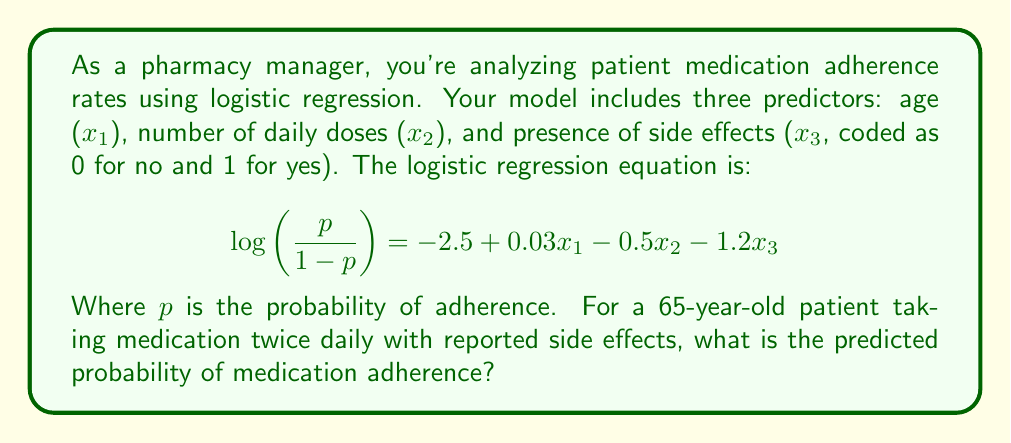Can you solve this math problem? To solve this problem, we'll follow these steps:

1. Identify the values for each predictor:
   $x_1$ (age) = 65
   $x_2$ (number of daily doses) = 2
   $x_3$ (presence of side effects) = 1

2. Substitute these values into the logistic regression equation:

   $$\log\left(\frac{p}{1-p}\right) = -2.5 + 0.03(65) - 0.5(2) - 1.2(1)$$

3. Calculate the right-hand side:

   $$\log\left(\frac{p}{1-p}\right) = -2.5 + 1.95 - 1 - 1.2 = -2.75$$

4. This gives us the log-odds. To find p, we need to apply the inverse logit function:

   $$p = \frac{e^{-2.75}}{1 + e^{-2.75}}$$

5. Calculate this value:

   $$p = \frac{0.0639}{1 + 0.0639} = 0.0601$$

6. Convert to a percentage:

   0.0601 * 100 = 6.01%

Therefore, the predicted probability of medication adherence for this patient is approximately 6.01%.
Answer: 6.01% 